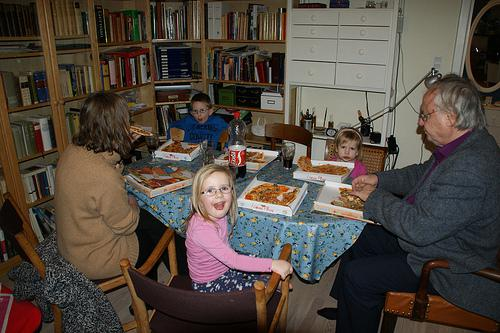Question: what is the main color of the tablecloth?
Choices:
A. Red.
B. Green.
C. Blue.
D. White.
Answer with the letter. Answer: C Question: how many people are there?
Choices:
A. Five.
B. Six.
C. Four.
D. Three.
Answer with the letter. Answer: A Question: how many pizzas are there?
Choices:
A. Five.
B. Six.
C. Three.
D. Four.
Answer with the letter. Answer: B Question: what color is the nearest girl's shirt?
Choices:
A. Pink.
B. Purple.
C. Blue.
D. Orange.
Answer with the letter. Answer: A Question: what color is the nearest man's jacket?
Choices:
A. Black.
B. White.
C. Red.
D. Gray.
Answer with the letter. Answer: D Question: what is the nearest man wearing on his eyes?
Choices:
A. Contact Lenses.
B. A sleep mask.
C. Glasses.
D. Welding goggles.
Answer with the letter. Answer: C 